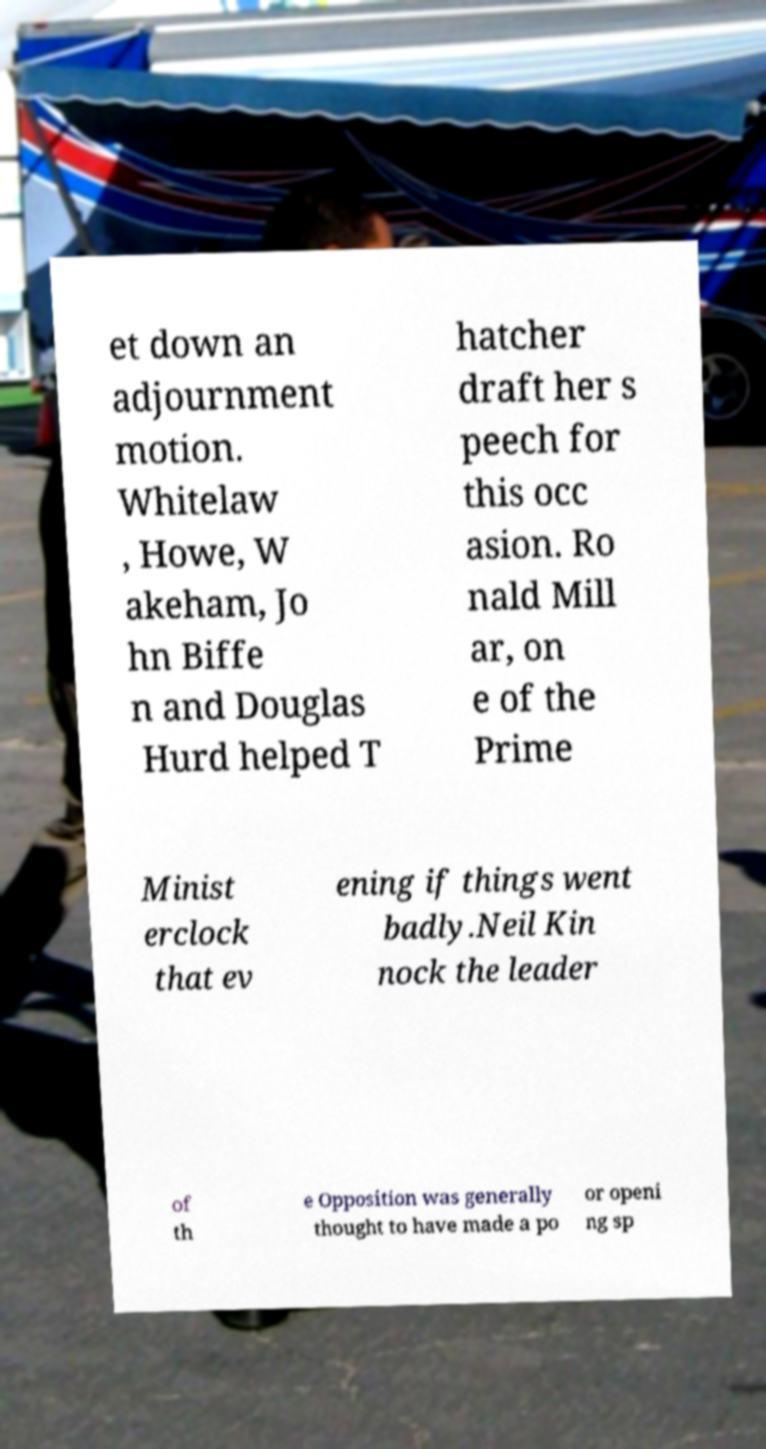What messages or text are displayed in this image? I need them in a readable, typed format. et down an adjournment motion. Whitelaw , Howe, W akeham, Jo hn Biffe n and Douglas Hurd helped T hatcher draft her s peech for this occ asion. Ro nald Mill ar, on e of the Prime Minist erclock that ev ening if things went badly.Neil Kin nock the leader of th e Opposition was generally thought to have made a po or openi ng sp 